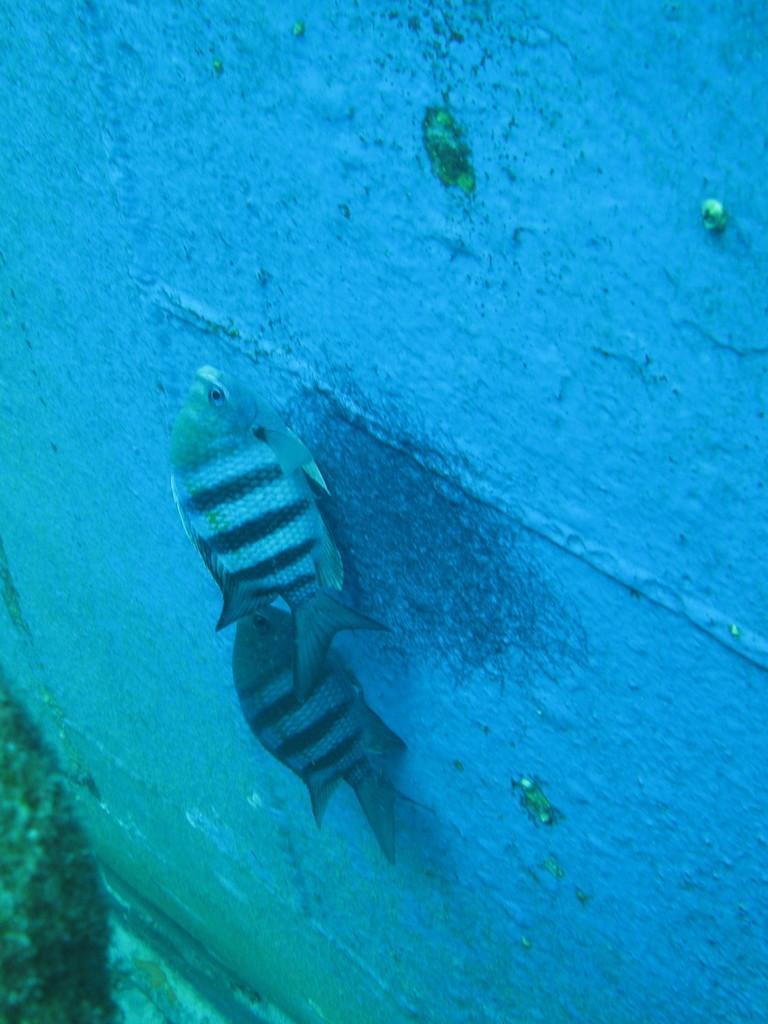Can you describe this image briefly? These are fishes, this is wall. 